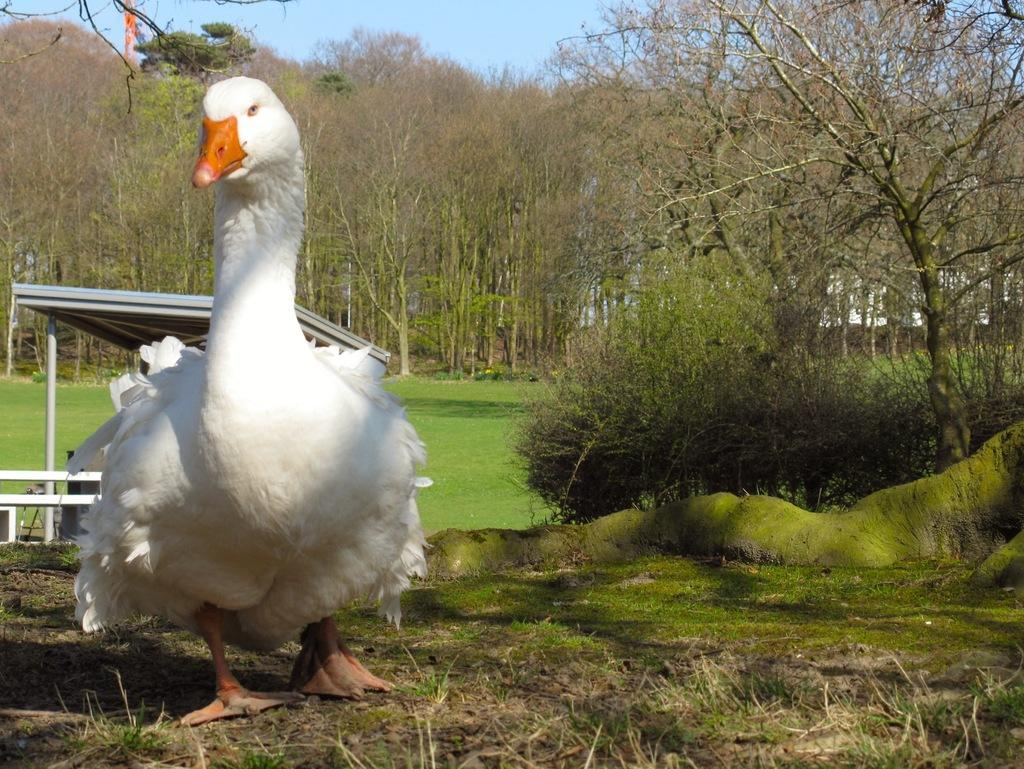What animal can be seen in the image? There is a duck in the image. What is the duck doing in the image? The duck is walking on the land. What type of terrain is the duck walking on? The land is covered with grass. What other natural elements can be seen in the image? There are trees in the image. Can you see any turkeys or pickles in the image? No, there are no turkeys or pickles present in the image. Are there any dinosaurs visible in the image? No, there are no dinosaurs visible in the image. 